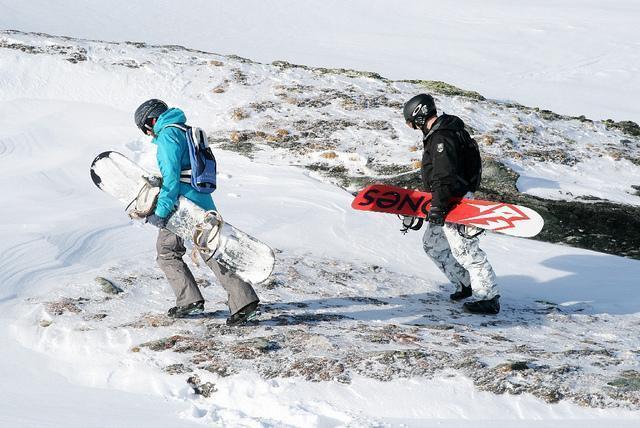How many snowboards are there?
Give a very brief answer. 2. How many people are visible?
Give a very brief answer. 2. How many giraffes are eating leaves?
Give a very brief answer. 0. 